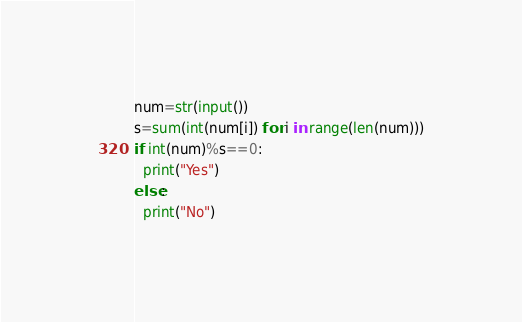Convert code to text. <code><loc_0><loc_0><loc_500><loc_500><_Python_>num=str(input())
s=sum(int(num[i]) for i in range(len(num)))
if int(num)%s==0:
  print("Yes")
else:
  print("No")</code> 